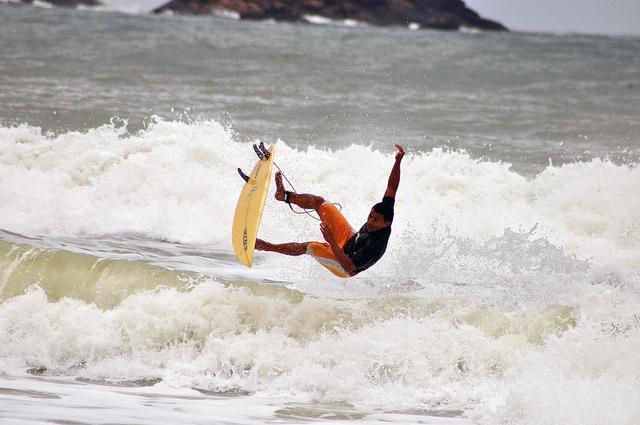How many elephants can be seen?
Give a very brief answer. 0. 